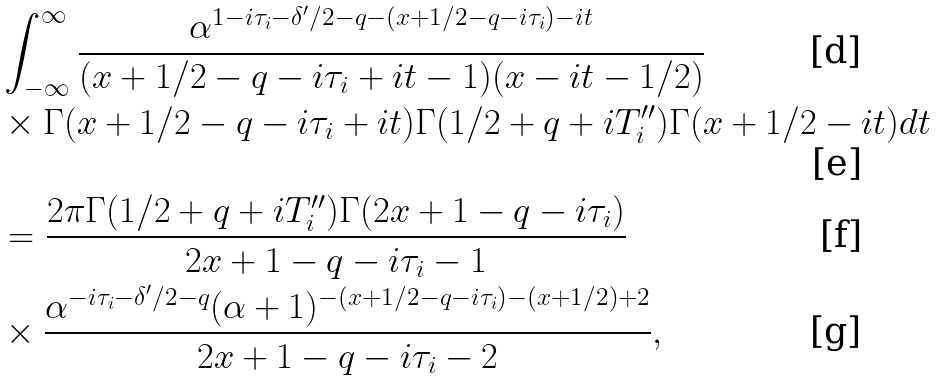<formula> <loc_0><loc_0><loc_500><loc_500>& \int _ { - \infty } ^ { \infty } \frac { \alpha ^ { 1 - i \tau _ { i } - \delta ^ { \prime } / 2 - q - ( x + 1 / 2 - q - i \tau _ { i } ) - i t } } { ( x + 1 / 2 - q - i \tau _ { i } + i t - 1 ) ( x - i t - 1 / 2 ) } \\ & \times \Gamma ( x + 1 / 2 - q - i \tau _ { i } + i t ) \Gamma ( 1 / 2 + q + i T _ { i } ^ { \prime \prime } ) \Gamma ( x + 1 / 2 - i t ) d t \\ & = \frac { 2 \pi \Gamma ( 1 / 2 + q + i T _ { i } ^ { \prime \prime } ) \Gamma ( 2 x + 1 - q - i \tau _ { i } ) } { 2 x + 1 - q - i \tau _ { i } - 1 } \\ & \times \frac { \alpha ^ { - i \tau _ { i } - \delta ^ { \prime } / 2 - q } ( \alpha + 1 ) ^ { - ( x + 1 / 2 - q - i \tau _ { i } ) - ( x + 1 / 2 ) + 2 } } { 2 x + 1 - q - i \tau _ { i } - 2 } ,</formula> 